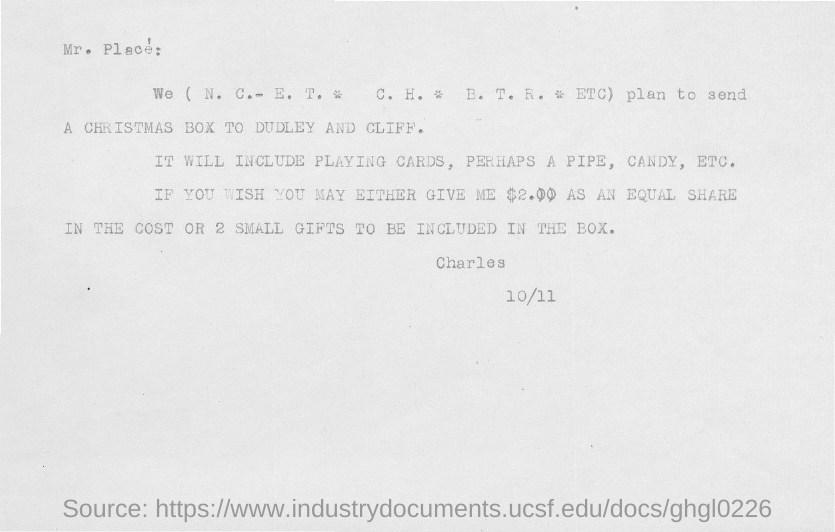Who is the sender of this document?
Provide a short and direct response. Charles. To whom, the document is addressed?
Ensure brevity in your answer.  Mr. Place'. 